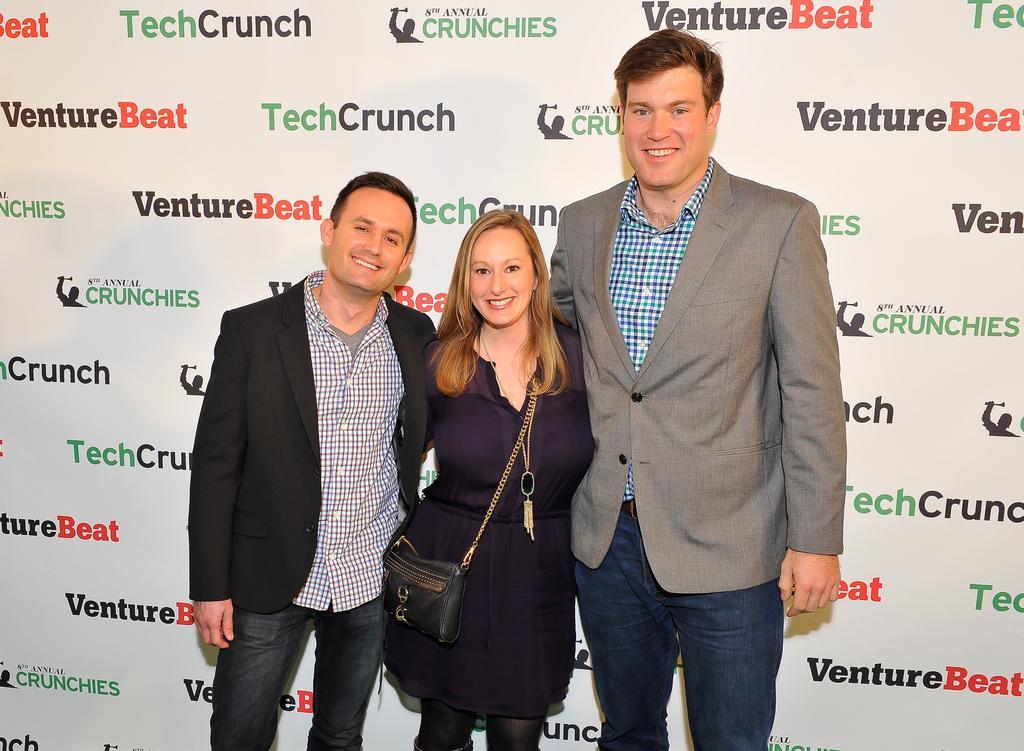Describe this image in one or two sentences. In the center of this picture we can see the two persons wearing blazer, smiling and standing and we can see a woman wearing black color dress, sling bag, smiling and standing. In the background we can see the text and some pictures on the banner. 